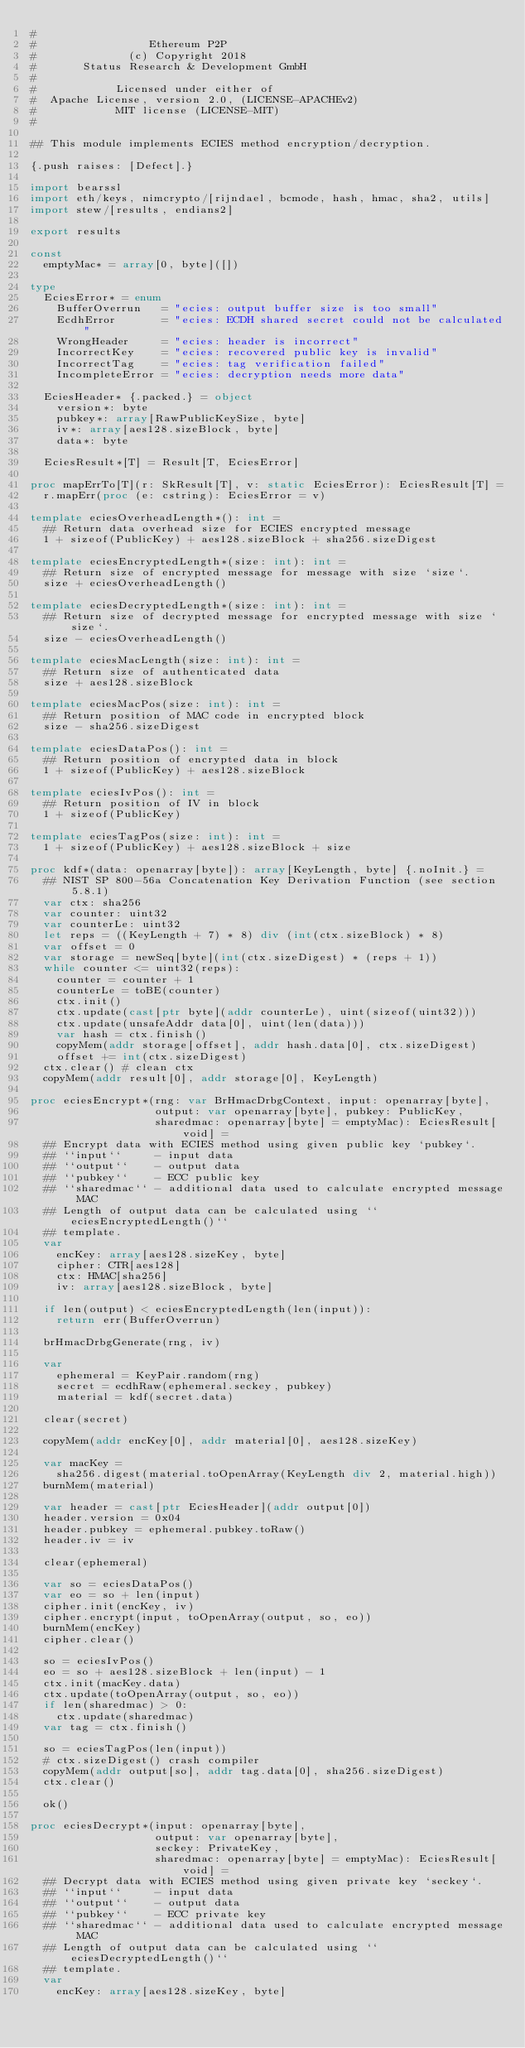Convert code to text. <code><loc_0><loc_0><loc_500><loc_500><_Nim_>#
#                 Ethereum P2P
#              (c) Copyright 2018
#       Status Research & Development GmbH
#
#            Licensed under either of
#  Apache License, version 2.0, (LICENSE-APACHEv2)
#            MIT license (LICENSE-MIT)
#

## This module implements ECIES method encryption/decryption.

{.push raises: [Defect].}

import bearssl
import eth/keys, nimcrypto/[rijndael, bcmode, hash, hmac, sha2, utils]
import stew/[results, endians2]

export results

const
  emptyMac* = array[0, byte]([])

type
  EciesError* = enum
    BufferOverrun   = "ecies: output buffer size is too small"
    EcdhError       = "ecies: ECDH shared secret could not be calculated"
    WrongHeader     = "ecies: header is incorrect"
    IncorrectKey    = "ecies: recovered public key is invalid"
    IncorrectTag    = "ecies: tag verification failed"
    IncompleteError = "ecies: decryption needs more data"

  EciesHeader* {.packed.} = object
    version*: byte
    pubkey*: array[RawPublicKeySize, byte]
    iv*: array[aes128.sizeBlock, byte]
    data*: byte

  EciesResult*[T] = Result[T, EciesError]

proc mapErrTo[T](r: SkResult[T], v: static EciesError): EciesResult[T] =
  r.mapErr(proc (e: cstring): EciesError = v)

template eciesOverheadLength*(): int =
  ## Return data overhead size for ECIES encrypted message
  1 + sizeof(PublicKey) + aes128.sizeBlock + sha256.sizeDigest

template eciesEncryptedLength*(size: int): int =
  ## Return size of encrypted message for message with size `size`.
  size + eciesOverheadLength()

template eciesDecryptedLength*(size: int): int =
  ## Return size of decrypted message for encrypted message with size `size`.
  size - eciesOverheadLength()

template eciesMacLength(size: int): int =
  ## Return size of authenticated data
  size + aes128.sizeBlock

template eciesMacPos(size: int): int =
  ## Return position of MAC code in encrypted block
  size - sha256.sizeDigest

template eciesDataPos(): int =
  ## Return position of encrypted data in block
  1 + sizeof(PublicKey) + aes128.sizeBlock

template eciesIvPos(): int =
  ## Return position of IV in block
  1 + sizeof(PublicKey)

template eciesTagPos(size: int): int =
  1 + sizeof(PublicKey) + aes128.sizeBlock + size

proc kdf*(data: openarray[byte]): array[KeyLength, byte] {.noInit.} =
  ## NIST SP 800-56a Concatenation Key Derivation Function (see section 5.8.1)
  var ctx: sha256
  var counter: uint32
  var counterLe: uint32
  let reps = ((KeyLength + 7) * 8) div (int(ctx.sizeBlock) * 8)
  var offset = 0
  var storage = newSeq[byte](int(ctx.sizeDigest) * (reps + 1))
  while counter <= uint32(reps):
    counter = counter + 1
    counterLe = toBE(counter)
    ctx.init()
    ctx.update(cast[ptr byte](addr counterLe), uint(sizeof(uint32)))
    ctx.update(unsafeAddr data[0], uint(len(data)))
    var hash = ctx.finish()
    copyMem(addr storage[offset], addr hash.data[0], ctx.sizeDigest)
    offset += int(ctx.sizeDigest)
  ctx.clear() # clean ctx
  copyMem(addr result[0], addr storage[0], KeyLength)

proc eciesEncrypt*(rng: var BrHmacDrbgContext, input: openarray[byte],
                   output: var openarray[byte], pubkey: PublicKey,
                   sharedmac: openarray[byte] = emptyMac): EciesResult[void] =
  ## Encrypt data with ECIES method using given public key `pubkey`.
  ## ``input``     - input data
  ## ``output``    - output data
  ## ``pubkey``    - ECC public key
  ## ``sharedmac`` - additional data used to calculate encrypted message MAC
  ## Length of output data can be calculated using ``eciesEncryptedLength()``
  ## template.
  var
    encKey: array[aes128.sizeKey, byte]
    cipher: CTR[aes128]
    ctx: HMAC[sha256]
    iv: array[aes128.sizeBlock, byte]

  if len(output) < eciesEncryptedLength(len(input)):
    return err(BufferOverrun)

  brHmacDrbgGenerate(rng, iv)

  var
    ephemeral = KeyPair.random(rng)
    secret = ecdhRaw(ephemeral.seckey, pubkey)
    material = kdf(secret.data)

  clear(secret)

  copyMem(addr encKey[0], addr material[0], aes128.sizeKey)

  var macKey =
    sha256.digest(material.toOpenArray(KeyLength div 2, material.high))
  burnMem(material)

  var header = cast[ptr EciesHeader](addr output[0])
  header.version = 0x04
  header.pubkey = ephemeral.pubkey.toRaw()
  header.iv = iv

  clear(ephemeral)

  var so = eciesDataPos()
  var eo = so + len(input)
  cipher.init(encKey, iv)
  cipher.encrypt(input, toOpenArray(output, so, eo))
  burnMem(encKey)
  cipher.clear()

  so = eciesIvPos()
  eo = so + aes128.sizeBlock + len(input) - 1
  ctx.init(macKey.data)
  ctx.update(toOpenArray(output, so, eo))
  if len(sharedmac) > 0:
    ctx.update(sharedmac)
  var tag = ctx.finish()

  so = eciesTagPos(len(input))
  # ctx.sizeDigest() crash compiler
  copyMem(addr output[so], addr tag.data[0], sha256.sizeDigest)
  ctx.clear()

  ok()

proc eciesDecrypt*(input: openarray[byte],
                   output: var openarray[byte],
                   seckey: PrivateKey,
                   sharedmac: openarray[byte] = emptyMac): EciesResult[void] =
  ## Decrypt data with ECIES method using given private key `seckey`.
  ## ``input``     - input data
  ## ``output``    - output data
  ## ``pubkey``    - ECC private key
  ## ``sharedmac`` - additional data used to calculate encrypted message MAC
  ## Length of output data can be calculated using ``eciesDecryptedLength()``
  ## template.
  var
    encKey: array[aes128.sizeKey, byte]</code> 